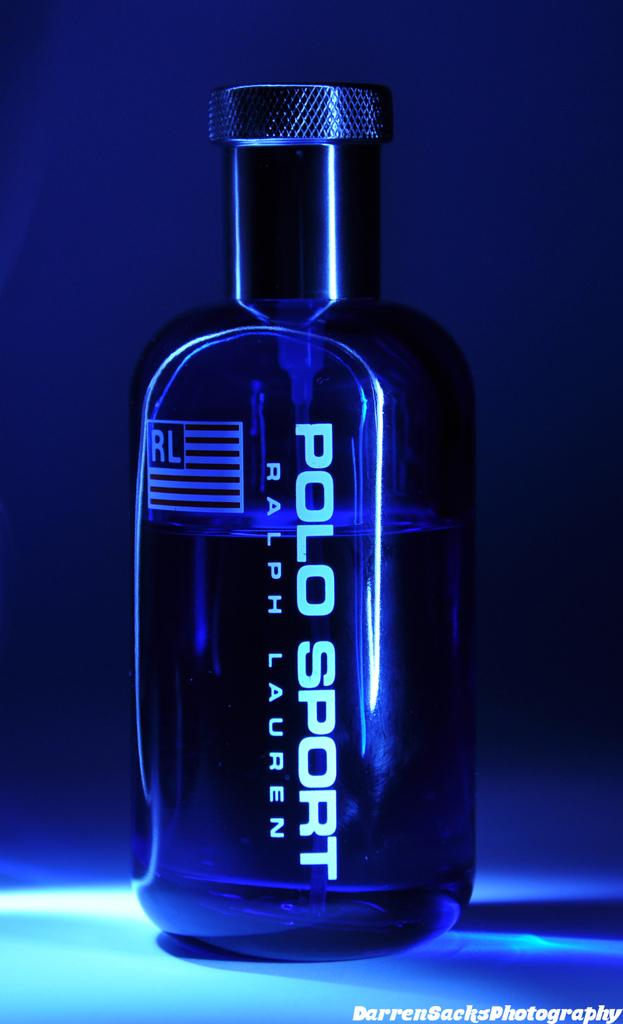<image>
Create a compact narrative representing the image presented. A  bottle with polo sport by Ralph Lauren written on it. 